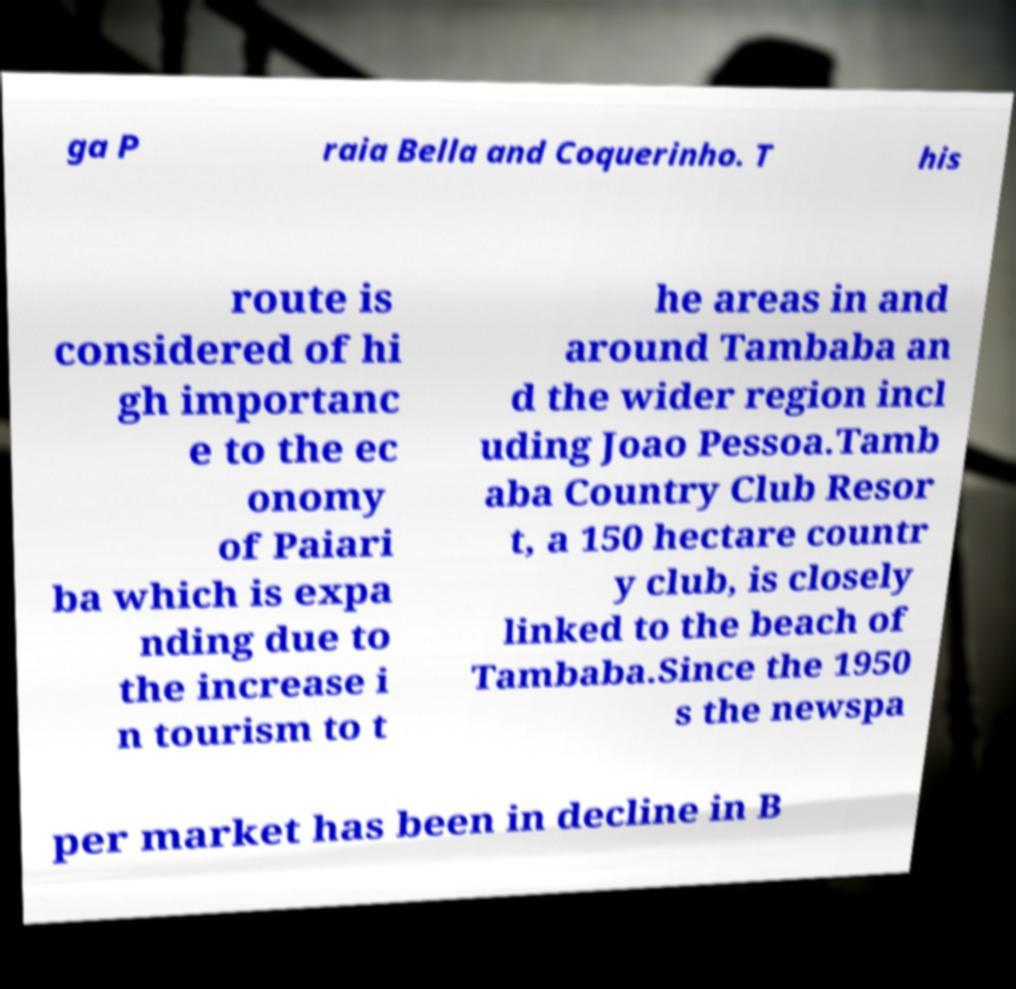There's text embedded in this image that I need extracted. Can you transcribe it verbatim? ga P raia Bella and Coquerinho. T his route is considered of hi gh importanc e to the ec onomy of Paiari ba which is expa nding due to the increase i n tourism to t he areas in and around Tambaba an d the wider region incl uding Joao Pessoa.Tamb aba Country Club Resor t, a 150 hectare countr y club, is closely linked to the beach of Tambaba.Since the 1950 s the newspa per market has been in decline in B 